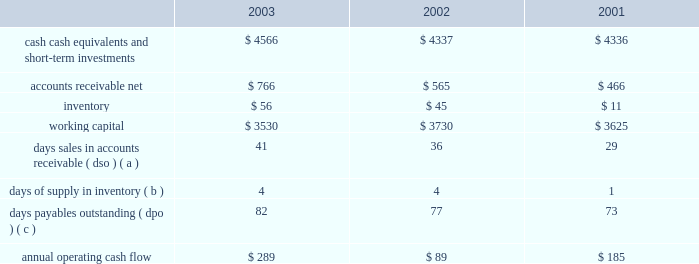30 of 93 liquidity and capital resources the table presents selected financial information and statistics for each of the last three fiscal years ( dollars in millions ) : .
( a ) dso is based on ending net trade receivables and most recent quarterly net sales for each period .
( b ) days supply of inventory is based on ending inventory and most recent quarterly cost of sales for each period .
( c ) dpo is based on ending accounts payable and most recent quarterly cost of sales adjusted for the change in inventory .
As of september 27 , 2003 , the company 2019s cash , cash equivalents , and short-term investments portfolio totaled $ 4.566 billion , an increase of $ 229 million from the end of fiscal 2002 .
The company 2019s short-term investment portfolio consists primarily of investments in u.s .
Treasury and agency securities , u.s .
Corporate securities , and foreign securities .
Foreign securities consist primarily of foreign commercial paper , certificates of deposit and time deposits with foreign institutions , most of which are denominated in u.s .
Dollars .
The company 2019s investments are generally liquid and investment grade .
As a result of declining investment yields on the company 2019s cash equivalents and short-term investments resulting from substantially lower market interest rates during 2003 , the company has elected to reduce the average maturity of its portfolio to maintain liquidity for future investment opportunities when market interest rates increase .
Accordingly , during 2003 the company increased its holdings in short-term investment grade instruments , both in u.s .
Corporate and foreign securities , that are classified as cash equivalents and has reduced its holdings in longer-term u.s .
Corporate securities classified as short-term investments .
Although the company 2019s cash , cash equivalents , and short-term investments increased in 2003 , the company 2019s working capital at september 27 , 2003 decreased by $ 200 million as compared to the end of fiscal 2002 due primarily to the current year reclassification of the company 2019s long-term debt as a current obligation resulting from its scheduled maturity in february 2004 .
The primary sources of total cash and cash equivalents in fiscal 2003 were $ 289 million in cash generated by operating activities and $ 53 million in proceeds from the issuance of common stock , partially offset by $ 164 million utilized for capital expenditures and $ 26 million for the repurchase of common stock .
The company believes its existing balances of cash , cash equivalents , and short-term investments will be sufficient to satisfy its working capital needs , capital expenditures , debt obligations , stock repurchase activity , outstanding commitments , and other liquidity requirements associated with its existing operations over the next 12 months .
The company currently has debt outstanding in the form of $ 300 million of aggregate principal amount 6.5% ( 6.5 % ) unsecured notes that were originally issued in 1994 .
The notes , which pay interest semiannually , were sold at 99.925% ( 99.925 % ) of par , for an effective yield to maturity of 6.51% ( 6.51 % ) .
The notes , along with approximately $ 4 million of unamortized deferred gains on closed interest rate swaps , are due in february 2004 and therefore have been classified as current debt as of september 27 , 2003 .
The company currently anticipates utilizing its existing cash balances to settle these notes when due .
Capital expenditures the company 2019s total capital expenditures were $ 164 million during fiscal 2003 , $ 92 million of which were for retail store facilities and equipment related to the company 2019s retail segment and $ 72 million of which were primarily for corporate infrastructure , including information systems enhancements and operating facilities enhancements and expansions .
The company currently anticipates it will utilize approximately $ 160 million for capital expenditures during 2004 , approximately $ 85 million of which is expected to be utilized for further expansion of the company 2019s retail segment and the remainder utilized to support normal replacement of existing capital assets and enhancements to general information technology infrastructure .
Stock repurchase plan in july 1999 , the company's board of directors authorized a plan for the company to repurchase up to $ 500 million of its common stock .
This repurchase plan does not obligate the company to acquire any specific number of shares or acquire shares over any specified period of time. .
What was the lowest inventory amount , in millions? 
Computations: table_min(inventory, none)
Answer: 11.0. 